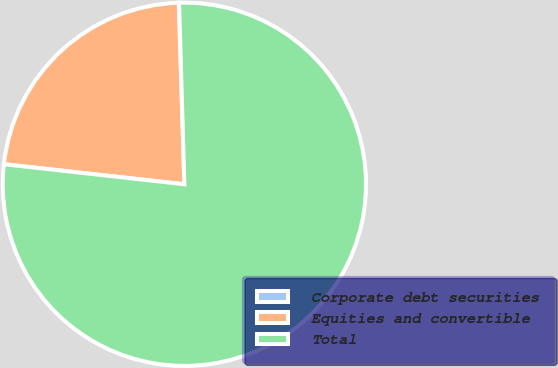Convert chart. <chart><loc_0><loc_0><loc_500><loc_500><pie_chart><fcel>Corporate debt securities<fcel>Equities and convertible<fcel>Total<nl><fcel>0.03%<fcel>22.74%<fcel>77.22%<nl></chart> 